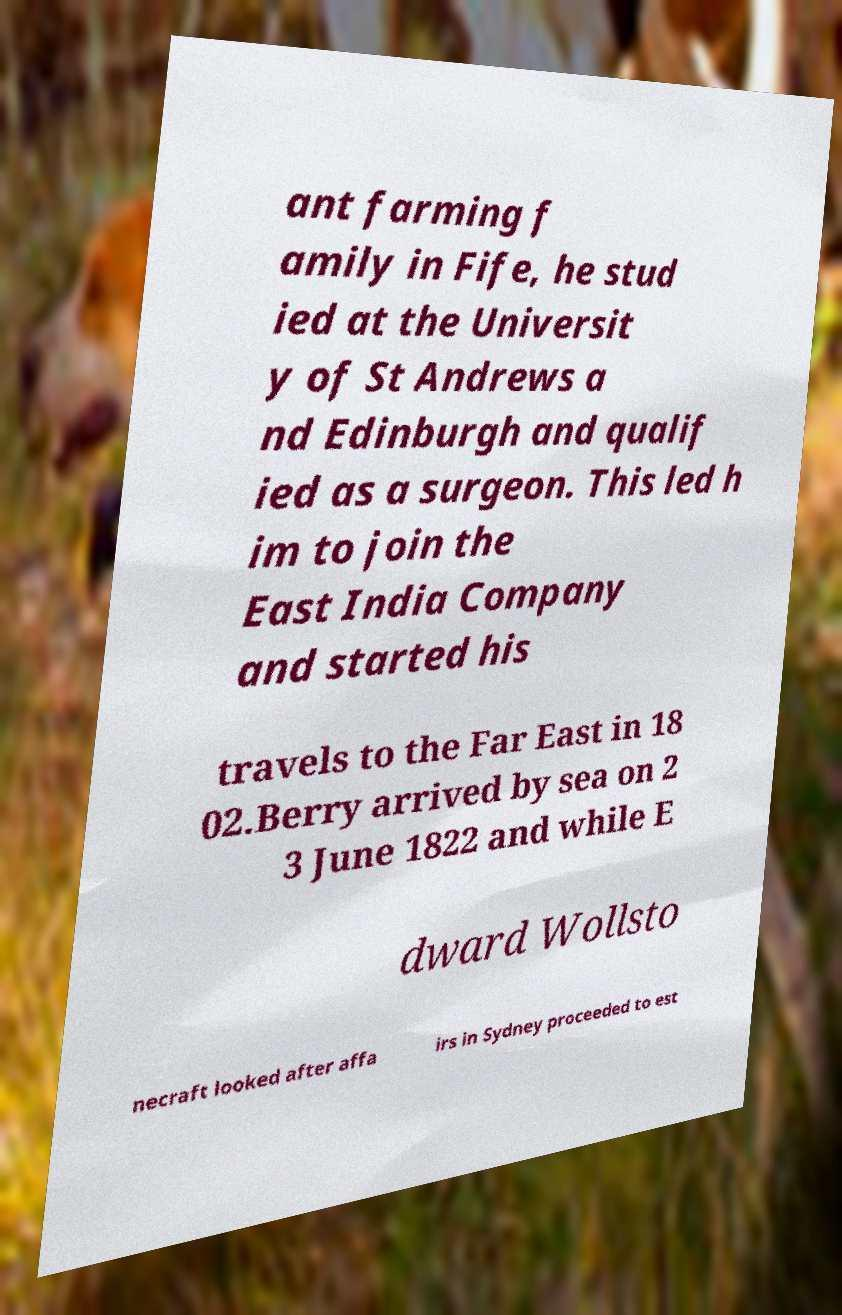What messages or text are displayed in this image? I need them in a readable, typed format. ant farming f amily in Fife, he stud ied at the Universit y of St Andrews a nd Edinburgh and qualif ied as a surgeon. This led h im to join the East India Company and started his travels to the Far East in 18 02.Berry arrived by sea on 2 3 June 1822 and while E dward Wollsto necraft looked after affa irs in Sydney proceeded to est 